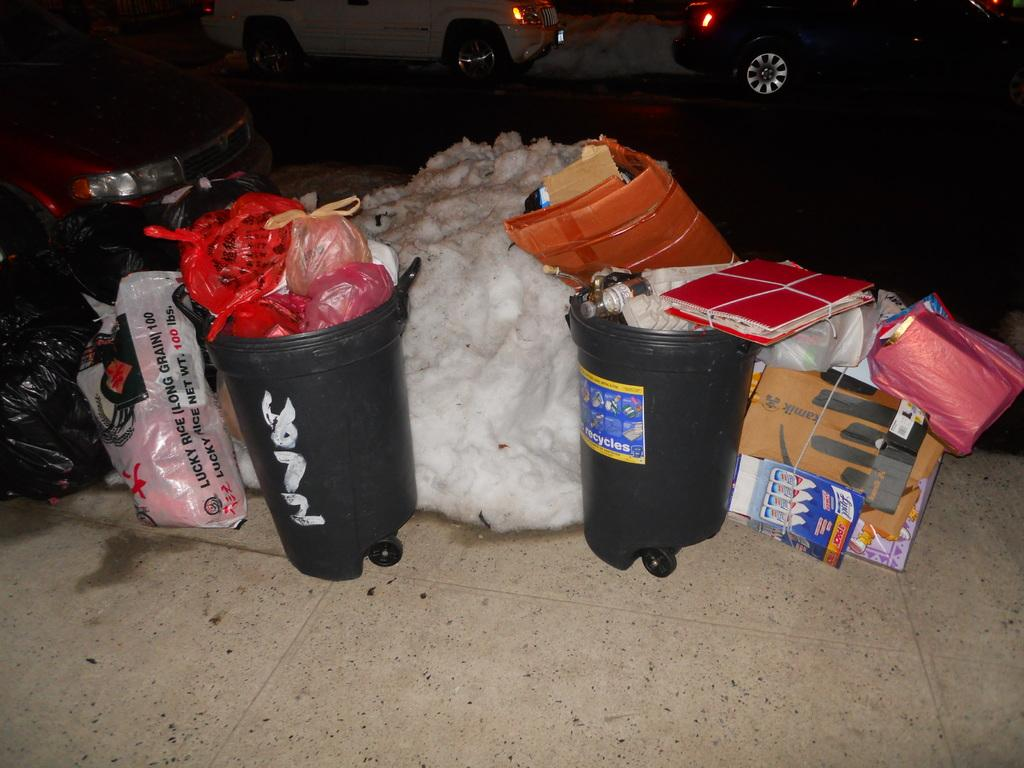<image>
Summarize the visual content of the image. A pile of trash on the sidewalk includes a trash can with the # 872 painted on it, a bag of Lucky Rice, and a box that says Kamik. 